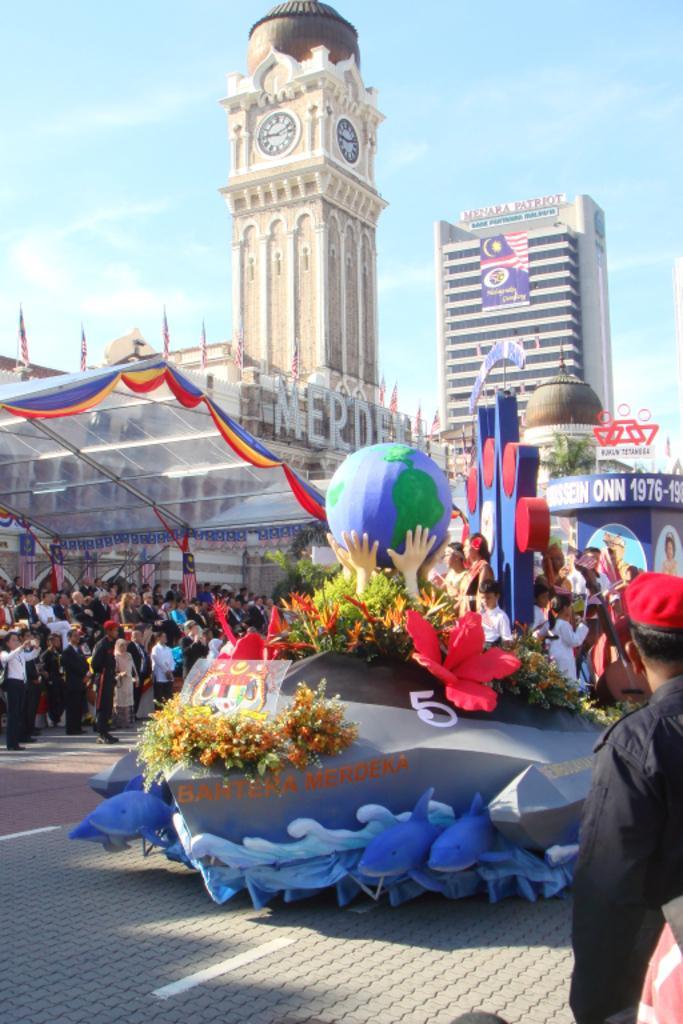Please provide a concise description of this image. In the front of the image there are people, boards, clock tower, building, curtains, flags, tent, plants, statue and objects. Among them few boards are on the building. Something is written on the boards. In the background of the image there is the sky. 